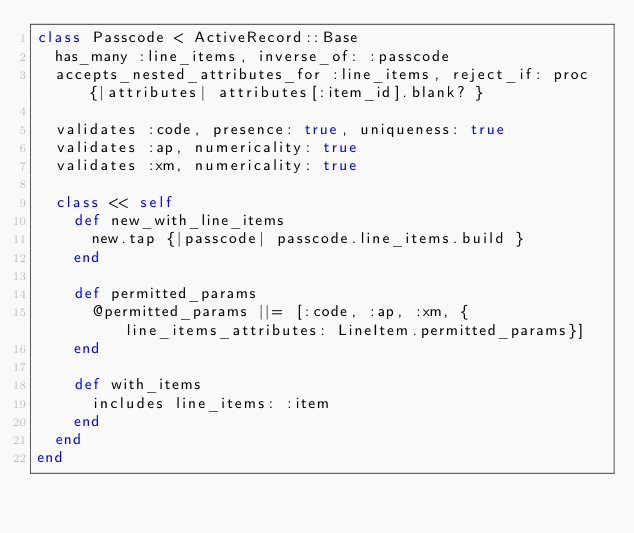<code> <loc_0><loc_0><loc_500><loc_500><_Ruby_>class Passcode < ActiveRecord::Base
  has_many :line_items, inverse_of: :passcode
  accepts_nested_attributes_for :line_items, reject_if: proc {|attributes| attributes[:item_id].blank? }

  validates :code, presence: true, uniqueness: true
  validates :ap, numericality: true
  validates :xm, numericality: true

  class << self
    def new_with_line_items
      new.tap {|passcode| passcode.line_items.build }
    end

    def permitted_params
      @permitted_params ||= [:code, :ap, :xm, {line_items_attributes: LineItem.permitted_params}]
    end

    def with_items
      includes line_items: :item
    end
  end
end
</code> 